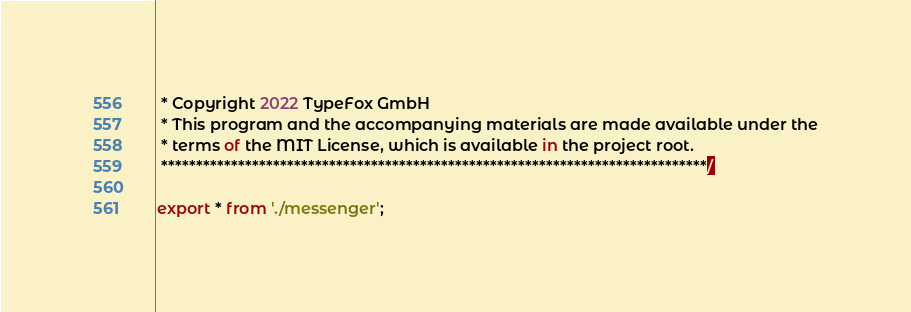<code> <loc_0><loc_0><loc_500><loc_500><_TypeScript_> * Copyright 2022 TypeFox GmbH
 * This program and the accompanying materials are made available under the
 * terms of the MIT License, which is available in the project root.
 ******************************************************************************/

export * from './messenger';
</code> 